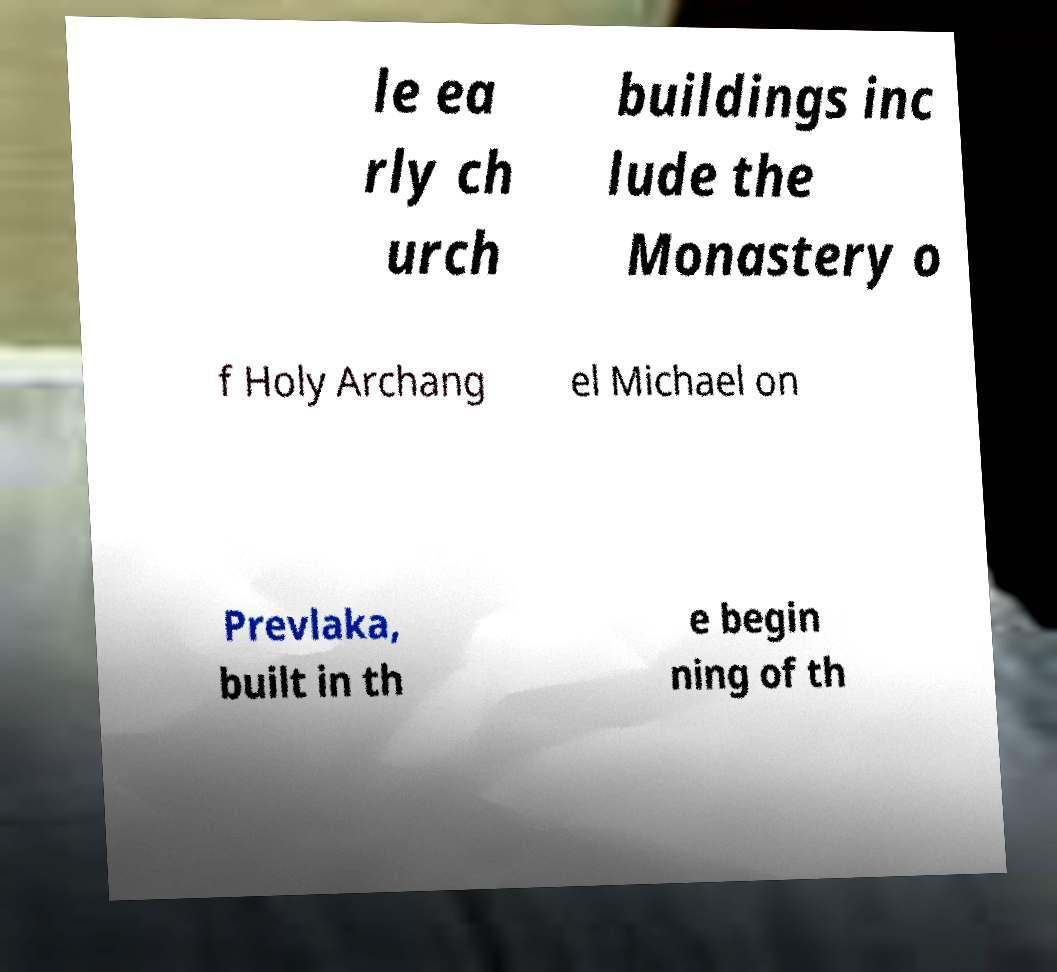What messages or text are displayed in this image? I need them in a readable, typed format. le ea rly ch urch buildings inc lude the Monastery o f Holy Archang el Michael on Prevlaka, built in th e begin ning of th 